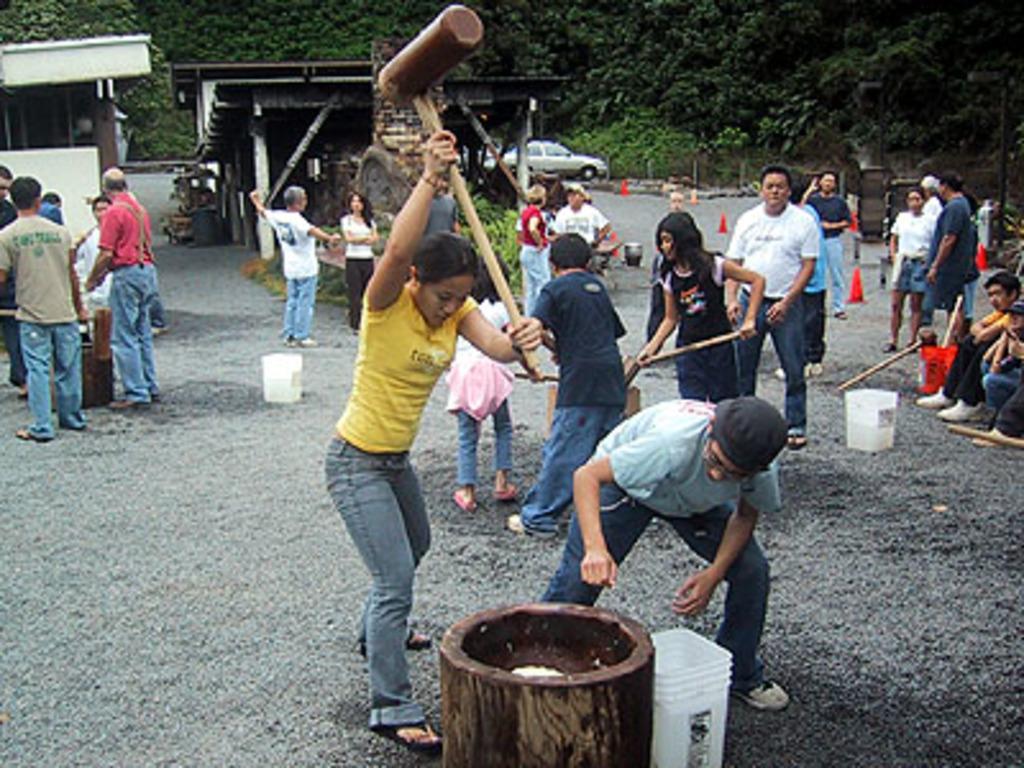In one or two sentences, can you explain what this image depicts? In this picture there is a woman who is wearing yellow t-shirt, jeans and sleeper. He is holding a wooden hammer, beside her there is a man who is wearing spectacle, cap, shirt, trouser and shoe. He is standing near to the bucket and wooden basket. In that there is a water. On the left i can see the group of persons were standing near to the table. On the right i can see another group of persons were sitting and some people were standing near to the baskets. In the background i can see the shed and car. Beside that there is a traffic cone. At the top i can see many trees. 